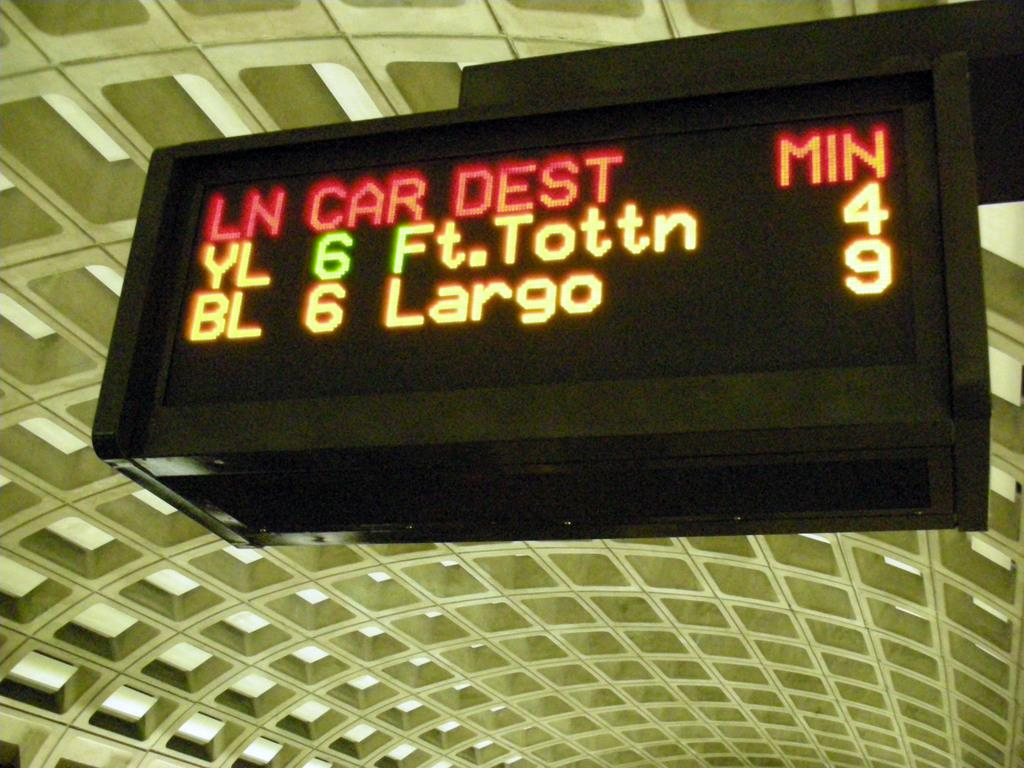<image>
Describe the image concisely. A digital sign lists minutes on the right side. 